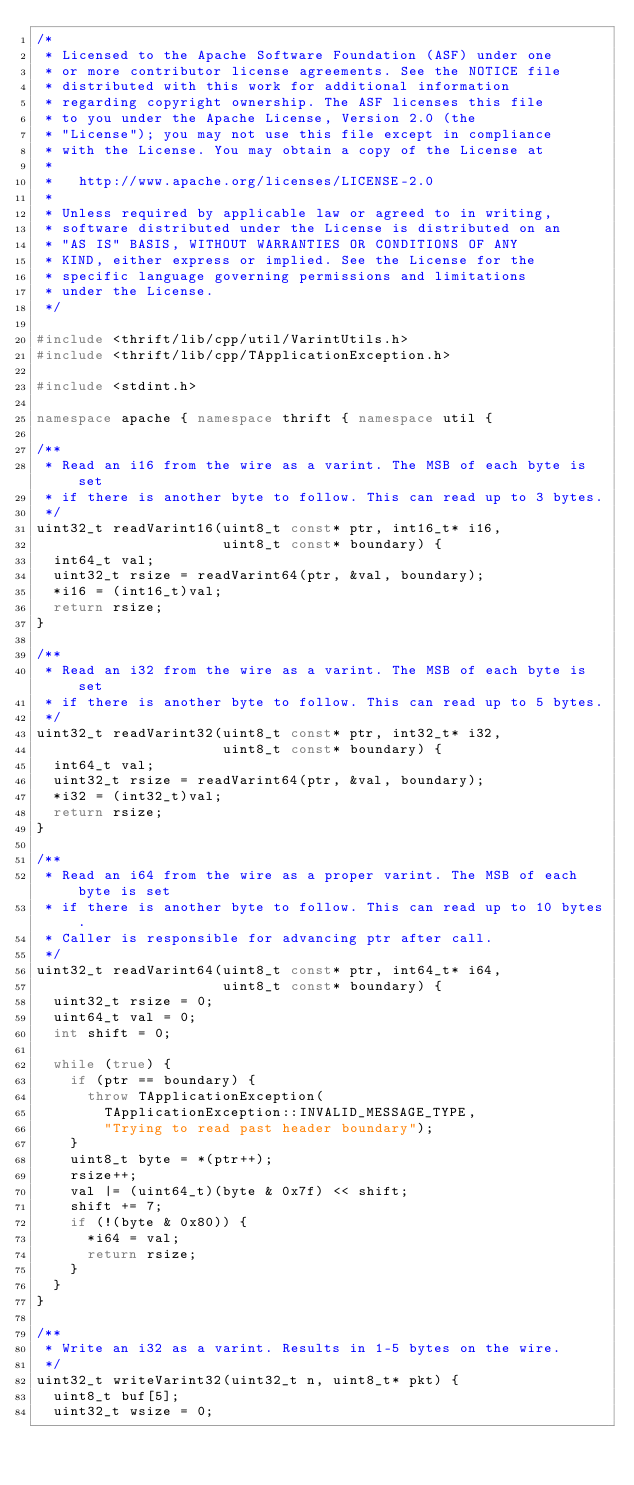<code> <loc_0><loc_0><loc_500><loc_500><_C++_>/*
 * Licensed to the Apache Software Foundation (ASF) under one
 * or more contributor license agreements. See the NOTICE file
 * distributed with this work for additional information
 * regarding copyright ownership. The ASF licenses this file
 * to you under the Apache License, Version 2.0 (the
 * "License"); you may not use this file except in compliance
 * with the License. You may obtain a copy of the License at
 *
 *   http://www.apache.org/licenses/LICENSE-2.0
 *
 * Unless required by applicable law or agreed to in writing,
 * software distributed under the License is distributed on an
 * "AS IS" BASIS, WITHOUT WARRANTIES OR CONDITIONS OF ANY
 * KIND, either express or implied. See the License for the
 * specific language governing permissions and limitations
 * under the License.
 */

#include <thrift/lib/cpp/util/VarintUtils.h>
#include <thrift/lib/cpp/TApplicationException.h>

#include <stdint.h>

namespace apache { namespace thrift { namespace util {

/**
 * Read an i16 from the wire as a varint. The MSB of each byte is set
 * if there is another byte to follow. This can read up to 3 bytes.
 */
uint32_t readVarint16(uint8_t const* ptr, int16_t* i16,
                      uint8_t const* boundary) {
  int64_t val;
  uint32_t rsize = readVarint64(ptr, &val, boundary);
  *i16 = (int16_t)val;
  return rsize;
}

/**
 * Read an i32 from the wire as a varint. The MSB of each byte is set
 * if there is another byte to follow. This can read up to 5 bytes.
 */
uint32_t readVarint32(uint8_t const* ptr, int32_t* i32,
                      uint8_t const* boundary) {
  int64_t val;
  uint32_t rsize = readVarint64(ptr, &val, boundary);
  *i32 = (int32_t)val;
  return rsize;
}

/**
 * Read an i64 from the wire as a proper varint. The MSB of each byte is set
 * if there is another byte to follow. This can read up to 10 bytes.
 * Caller is responsible for advancing ptr after call.
 */
uint32_t readVarint64(uint8_t const* ptr, int64_t* i64,
                      uint8_t const* boundary) {
  uint32_t rsize = 0;
  uint64_t val = 0;
  int shift = 0;

  while (true) {
    if (ptr == boundary) {
      throw TApplicationException(
        TApplicationException::INVALID_MESSAGE_TYPE,
        "Trying to read past header boundary");
    }
    uint8_t byte = *(ptr++);
    rsize++;
    val |= (uint64_t)(byte & 0x7f) << shift;
    shift += 7;
    if (!(byte & 0x80)) {
      *i64 = val;
      return rsize;
    }
  }
}

/**
 * Write an i32 as a varint. Results in 1-5 bytes on the wire.
 */
uint32_t writeVarint32(uint32_t n, uint8_t* pkt) {
  uint8_t buf[5];
  uint32_t wsize = 0;
</code> 